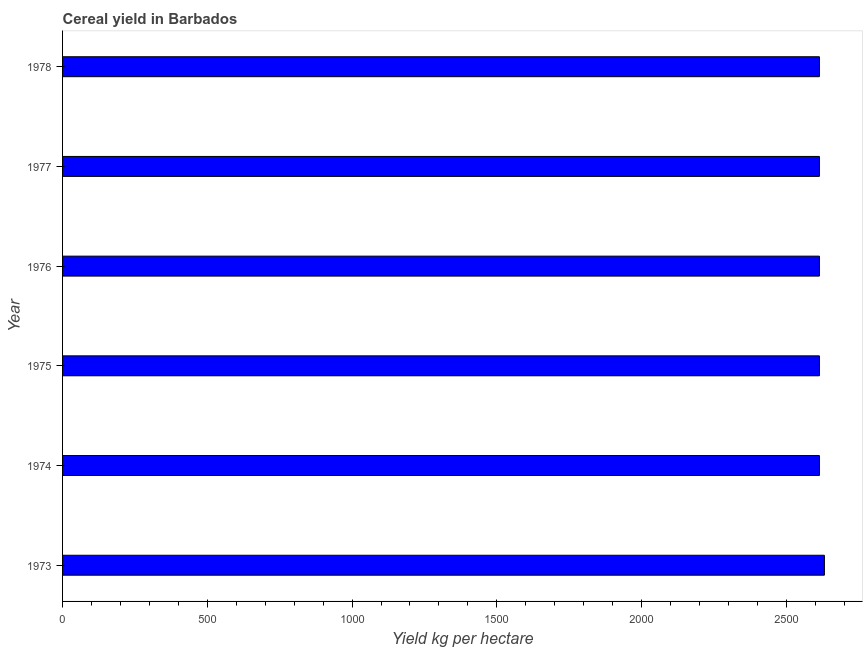Does the graph contain any zero values?
Ensure brevity in your answer.  No. Does the graph contain grids?
Offer a very short reply. No. What is the title of the graph?
Your response must be concise. Cereal yield in Barbados. What is the label or title of the X-axis?
Make the answer very short. Yield kg per hectare. What is the label or title of the Y-axis?
Offer a terse response. Year. What is the cereal yield in 1976?
Give a very brief answer. 2614.38. Across all years, what is the maximum cereal yield?
Ensure brevity in your answer.  2631.58. Across all years, what is the minimum cereal yield?
Offer a terse response. 2614.38. In which year was the cereal yield minimum?
Ensure brevity in your answer.  1974. What is the sum of the cereal yield?
Make the answer very short. 1.57e+04. What is the difference between the cereal yield in 1975 and 1976?
Your response must be concise. 0. What is the average cereal yield per year?
Provide a succinct answer. 2617.25. What is the median cereal yield?
Keep it short and to the point. 2614.38. In how many years, is the cereal yield greater than 600 kg per hectare?
Your response must be concise. 6. Is the difference between the cereal yield in 1976 and 1977 greater than the difference between any two years?
Your answer should be compact. No. Is the sum of the cereal yield in 1973 and 1976 greater than the maximum cereal yield across all years?
Your answer should be compact. Yes. In how many years, is the cereal yield greater than the average cereal yield taken over all years?
Provide a succinct answer. 1. How many years are there in the graph?
Keep it short and to the point. 6. Are the values on the major ticks of X-axis written in scientific E-notation?
Offer a very short reply. No. What is the Yield kg per hectare in 1973?
Keep it short and to the point. 2631.58. What is the Yield kg per hectare in 1974?
Your answer should be compact. 2614.38. What is the Yield kg per hectare of 1975?
Make the answer very short. 2614.38. What is the Yield kg per hectare in 1976?
Keep it short and to the point. 2614.38. What is the Yield kg per hectare of 1977?
Give a very brief answer. 2614.38. What is the Yield kg per hectare in 1978?
Your answer should be very brief. 2614.38. What is the difference between the Yield kg per hectare in 1973 and 1974?
Make the answer very short. 17.2. What is the difference between the Yield kg per hectare in 1973 and 1976?
Offer a terse response. 17.2. What is the difference between the Yield kg per hectare in 1973 and 1978?
Your response must be concise. 17.2. What is the difference between the Yield kg per hectare in 1974 and 1975?
Offer a terse response. 0. What is the difference between the Yield kg per hectare in 1974 and 1976?
Your answer should be compact. 0. What is the difference between the Yield kg per hectare in 1975 and 1977?
Provide a short and direct response. 0. What is the ratio of the Yield kg per hectare in 1973 to that in 1975?
Provide a short and direct response. 1.01. What is the ratio of the Yield kg per hectare in 1973 to that in 1976?
Your answer should be very brief. 1.01. What is the ratio of the Yield kg per hectare in 1974 to that in 1977?
Offer a very short reply. 1. What is the ratio of the Yield kg per hectare in 1974 to that in 1978?
Offer a terse response. 1. What is the ratio of the Yield kg per hectare in 1975 to that in 1977?
Ensure brevity in your answer.  1. What is the ratio of the Yield kg per hectare in 1976 to that in 1977?
Offer a very short reply. 1. What is the ratio of the Yield kg per hectare in 1976 to that in 1978?
Ensure brevity in your answer.  1. What is the ratio of the Yield kg per hectare in 1977 to that in 1978?
Your answer should be very brief. 1. 